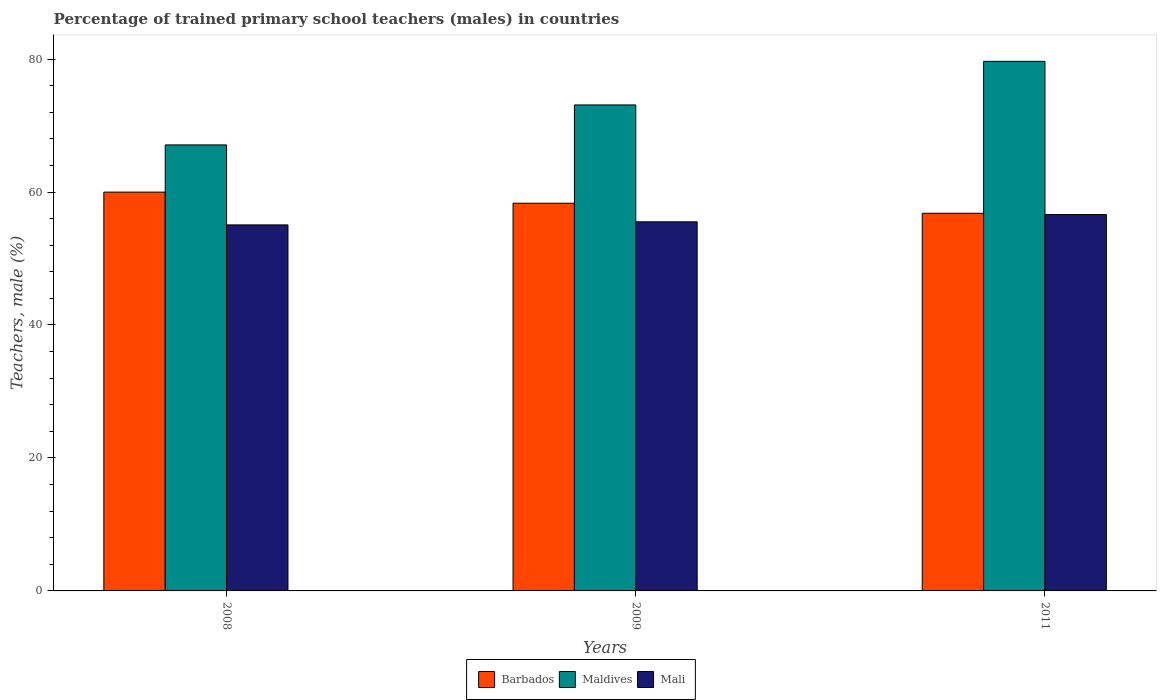How many bars are there on the 3rd tick from the left?
Your answer should be very brief. 3. What is the percentage of trained primary school teachers (males) in Barbados in 2008?
Provide a short and direct response. 59.99. Across all years, what is the maximum percentage of trained primary school teachers (males) in Maldives?
Your answer should be compact. 79.65. Across all years, what is the minimum percentage of trained primary school teachers (males) in Maldives?
Provide a succinct answer. 67.08. In which year was the percentage of trained primary school teachers (males) in Barbados maximum?
Offer a very short reply. 2008. What is the total percentage of trained primary school teachers (males) in Barbados in the graph?
Your answer should be compact. 175.1. What is the difference between the percentage of trained primary school teachers (males) in Barbados in 2008 and that in 2009?
Your answer should be compact. 1.67. What is the difference between the percentage of trained primary school teachers (males) in Barbados in 2008 and the percentage of trained primary school teachers (males) in Mali in 2011?
Provide a succinct answer. 3.38. What is the average percentage of trained primary school teachers (males) in Mali per year?
Give a very brief answer. 55.73. In the year 2009, what is the difference between the percentage of trained primary school teachers (males) in Barbados and percentage of trained primary school teachers (males) in Maldives?
Make the answer very short. -14.79. In how many years, is the percentage of trained primary school teachers (males) in Maldives greater than 36 %?
Your answer should be compact. 3. What is the ratio of the percentage of trained primary school teachers (males) in Barbados in 2009 to that in 2011?
Offer a terse response. 1.03. Is the difference between the percentage of trained primary school teachers (males) in Barbados in 2008 and 2011 greater than the difference between the percentage of trained primary school teachers (males) in Maldives in 2008 and 2011?
Ensure brevity in your answer.  Yes. What is the difference between the highest and the second highest percentage of trained primary school teachers (males) in Mali?
Make the answer very short. 1.09. What is the difference between the highest and the lowest percentage of trained primary school teachers (males) in Mali?
Your answer should be compact. 1.55. Is the sum of the percentage of trained primary school teachers (males) in Mali in 2009 and 2011 greater than the maximum percentage of trained primary school teachers (males) in Barbados across all years?
Give a very brief answer. Yes. What does the 3rd bar from the left in 2011 represents?
Your response must be concise. Mali. What does the 3rd bar from the right in 2009 represents?
Your answer should be compact. Barbados. How many bars are there?
Provide a succinct answer. 9. What is the difference between two consecutive major ticks on the Y-axis?
Your response must be concise. 20. What is the title of the graph?
Ensure brevity in your answer.  Percentage of trained primary school teachers (males) in countries. Does "Sao Tome and Principe" appear as one of the legend labels in the graph?
Keep it short and to the point. No. What is the label or title of the X-axis?
Your answer should be compact. Years. What is the label or title of the Y-axis?
Offer a terse response. Teachers, male (%). What is the Teachers, male (%) of Barbados in 2008?
Offer a terse response. 59.99. What is the Teachers, male (%) in Maldives in 2008?
Keep it short and to the point. 67.08. What is the Teachers, male (%) in Mali in 2008?
Make the answer very short. 55.05. What is the Teachers, male (%) in Barbados in 2009?
Offer a very short reply. 58.31. What is the Teachers, male (%) of Maldives in 2009?
Make the answer very short. 73.1. What is the Teachers, male (%) of Mali in 2009?
Offer a very short reply. 55.52. What is the Teachers, male (%) of Barbados in 2011?
Your response must be concise. 56.8. What is the Teachers, male (%) in Maldives in 2011?
Give a very brief answer. 79.65. What is the Teachers, male (%) in Mali in 2011?
Make the answer very short. 56.61. Across all years, what is the maximum Teachers, male (%) of Barbados?
Your answer should be compact. 59.99. Across all years, what is the maximum Teachers, male (%) of Maldives?
Offer a very short reply. 79.65. Across all years, what is the maximum Teachers, male (%) of Mali?
Provide a succinct answer. 56.61. Across all years, what is the minimum Teachers, male (%) of Barbados?
Ensure brevity in your answer.  56.8. Across all years, what is the minimum Teachers, male (%) in Maldives?
Make the answer very short. 67.08. Across all years, what is the minimum Teachers, male (%) in Mali?
Offer a terse response. 55.05. What is the total Teachers, male (%) of Barbados in the graph?
Provide a succinct answer. 175.1. What is the total Teachers, male (%) in Maldives in the graph?
Provide a succinct answer. 219.84. What is the total Teachers, male (%) of Mali in the graph?
Your answer should be very brief. 167.18. What is the difference between the Teachers, male (%) of Barbados in 2008 and that in 2009?
Your answer should be very brief. 1.67. What is the difference between the Teachers, male (%) of Maldives in 2008 and that in 2009?
Your response must be concise. -6.01. What is the difference between the Teachers, male (%) of Mali in 2008 and that in 2009?
Make the answer very short. -0.46. What is the difference between the Teachers, male (%) in Barbados in 2008 and that in 2011?
Provide a short and direct response. 3.18. What is the difference between the Teachers, male (%) of Maldives in 2008 and that in 2011?
Offer a very short reply. -12.57. What is the difference between the Teachers, male (%) of Mali in 2008 and that in 2011?
Provide a succinct answer. -1.55. What is the difference between the Teachers, male (%) in Barbados in 2009 and that in 2011?
Offer a terse response. 1.51. What is the difference between the Teachers, male (%) in Maldives in 2009 and that in 2011?
Keep it short and to the point. -6.55. What is the difference between the Teachers, male (%) in Mali in 2009 and that in 2011?
Offer a terse response. -1.09. What is the difference between the Teachers, male (%) in Barbados in 2008 and the Teachers, male (%) in Maldives in 2009?
Make the answer very short. -13.11. What is the difference between the Teachers, male (%) of Barbados in 2008 and the Teachers, male (%) of Mali in 2009?
Ensure brevity in your answer.  4.47. What is the difference between the Teachers, male (%) in Maldives in 2008 and the Teachers, male (%) in Mali in 2009?
Your response must be concise. 11.57. What is the difference between the Teachers, male (%) in Barbados in 2008 and the Teachers, male (%) in Maldives in 2011?
Give a very brief answer. -19.67. What is the difference between the Teachers, male (%) in Barbados in 2008 and the Teachers, male (%) in Mali in 2011?
Your answer should be very brief. 3.38. What is the difference between the Teachers, male (%) of Maldives in 2008 and the Teachers, male (%) of Mali in 2011?
Give a very brief answer. 10.48. What is the difference between the Teachers, male (%) in Barbados in 2009 and the Teachers, male (%) in Maldives in 2011?
Offer a terse response. -21.34. What is the difference between the Teachers, male (%) of Barbados in 2009 and the Teachers, male (%) of Mali in 2011?
Offer a very short reply. 1.71. What is the difference between the Teachers, male (%) of Maldives in 2009 and the Teachers, male (%) of Mali in 2011?
Provide a succinct answer. 16.49. What is the average Teachers, male (%) in Barbados per year?
Keep it short and to the point. 58.37. What is the average Teachers, male (%) in Maldives per year?
Ensure brevity in your answer.  73.28. What is the average Teachers, male (%) in Mali per year?
Offer a terse response. 55.73. In the year 2008, what is the difference between the Teachers, male (%) in Barbados and Teachers, male (%) in Maldives?
Keep it short and to the point. -7.1. In the year 2008, what is the difference between the Teachers, male (%) of Barbados and Teachers, male (%) of Mali?
Your answer should be very brief. 4.93. In the year 2008, what is the difference between the Teachers, male (%) of Maldives and Teachers, male (%) of Mali?
Your answer should be compact. 12.03. In the year 2009, what is the difference between the Teachers, male (%) of Barbados and Teachers, male (%) of Maldives?
Give a very brief answer. -14.79. In the year 2009, what is the difference between the Teachers, male (%) in Barbados and Teachers, male (%) in Mali?
Offer a terse response. 2.8. In the year 2009, what is the difference between the Teachers, male (%) of Maldives and Teachers, male (%) of Mali?
Make the answer very short. 17.58. In the year 2011, what is the difference between the Teachers, male (%) of Barbados and Teachers, male (%) of Maldives?
Your response must be concise. -22.85. In the year 2011, what is the difference between the Teachers, male (%) in Barbados and Teachers, male (%) in Mali?
Make the answer very short. 0.2. In the year 2011, what is the difference between the Teachers, male (%) of Maldives and Teachers, male (%) of Mali?
Make the answer very short. 23.05. What is the ratio of the Teachers, male (%) of Barbados in 2008 to that in 2009?
Provide a short and direct response. 1.03. What is the ratio of the Teachers, male (%) in Maldives in 2008 to that in 2009?
Provide a short and direct response. 0.92. What is the ratio of the Teachers, male (%) of Mali in 2008 to that in 2009?
Provide a short and direct response. 0.99. What is the ratio of the Teachers, male (%) in Barbados in 2008 to that in 2011?
Provide a succinct answer. 1.06. What is the ratio of the Teachers, male (%) of Maldives in 2008 to that in 2011?
Your response must be concise. 0.84. What is the ratio of the Teachers, male (%) in Mali in 2008 to that in 2011?
Make the answer very short. 0.97. What is the ratio of the Teachers, male (%) in Barbados in 2009 to that in 2011?
Your answer should be very brief. 1.03. What is the ratio of the Teachers, male (%) of Maldives in 2009 to that in 2011?
Your answer should be very brief. 0.92. What is the ratio of the Teachers, male (%) of Mali in 2009 to that in 2011?
Keep it short and to the point. 0.98. What is the difference between the highest and the second highest Teachers, male (%) in Barbados?
Ensure brevity in your answer.  1.67. What is the difference between the highest and the second highest Teachers, male (%) of Maldives?
Ensure brevity in your answer.  6.55. What is the difference between the highest and the second highest Teachers, male (%) in Mali?
Make the answer very short. 1.09. What is the difference between the highest and the lowest Teachers, male (%) of Barbados?
Make the answer very short. 3.18. What is the difference between the highest and the lowest Teachers, male (%) in Maldives?
Your answer should be compact. 12.57. What is the difference between the highest and the lowest Teachers, male (%) in Mali?
Your response must be concise. 1.55. 